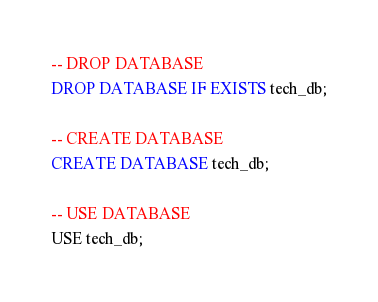Convert code to text. <code><loc_0><loc_0><loc_500><loc_500><_SQL_>-- DROP DATABASE
DROP DATABASE IF EXISTS tech_db;

-- CREATE DATABASE
CREATE DATABASE tech_db;

-- USE DATABASE
USE tech_db;</code> 